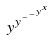<formula> <loc_0><loc_0><loc_500><loc_500>y ^ { y ^ { - ^ { - ^ { y ^ { x } } } } }</formula> 